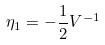<formula> <loc_0><loc_0><loc_500><loc_500>\eta _ { 1 } = - \frac { 1 } { 2 } V ^ { - 1 }</formula> 